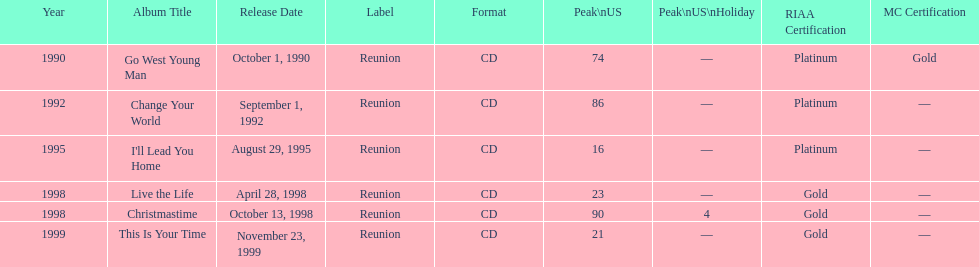The oldest year listed is what? 1990. Help me parse the entirety of this table. {'header': ['Year', 'Album Title', 'Release Date', 'Label', 'Format', 'Peak\\nUS', 'Peak\\nUS\\nHoliday', 'RIAA Certification', 'MC Certification'], 'rows': [['1990', 'Go West Young Man', 'October 1, 1990', 'Reunion', 'CD', '74', '—', 'Platinum', 'Gold'], ['1992', 'Change Your World', 'September 1, 1992', 'Reunion', 'CD', '86', '—', 'Platinum', '—'], ['1995', "I'll Lead You Home", 'August 29, 1995', 'Reunion', 'CD', '16', '—', 'Platinum', '—'], ['1998', 'Live the Life', 'April 28, 1998', 'Reunion', 'CD', '23', '—', 'Gold', '—'], ['1998', 'Christmastime', 'October 13, 1998', 'Reunion', 'CD', '90', '4', 'Gold', '—'], ['1999', 'This Is Your Time', 'November 23, 1999', 'Reunion', 'CD', '21', '—', 'Gold', '—']]} 